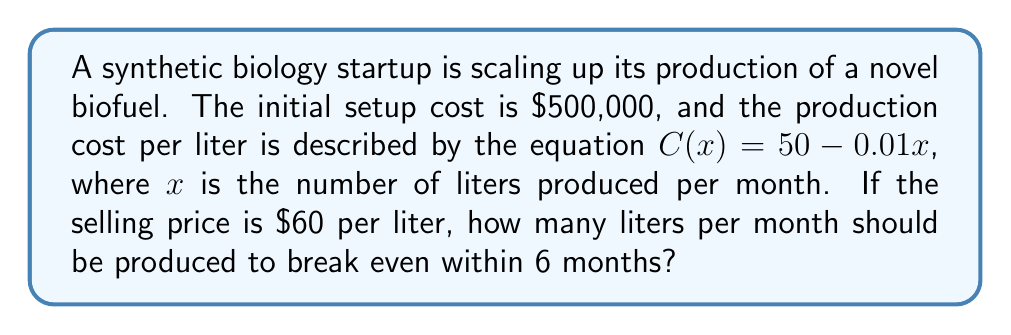Teach me how to tackle this problem. Let's approach this step-by-step:

1) First, let's define our variables:
   $x$ = number of liters produced per month
   $C(x)$ = production cost per liter
   $P$ = selling price per liter = $60

2) The total monthly revenue is given by:
   $R(x) = Px = 60x$

3) The total monthly cost is:
   $TC(x) = xC(x) = x(50 - 0.01x) = 50x - 0.01x^2$

4) The monthly profit is:
   $\pi(x) = R(x) - TC(x) = 60x - (50x - 0.01x^2) = 10x + 0.01x^2$

5) To break even within 6 months, the total profit should equal the initial setup cost:
   $6(10x + 0.01x^2) = 500,000$

6) Simplifying:
   $60x + 0.06x^2 = 500,000$
   $0.06x^2 + 60x - 500,000 = 0$

7) This is a quadratic equation. Let's solve it using the quadratic formula:
   $x = \frac{-b \pm \sqrt{b^2 - 4ac}}{2a}$

   Where $a = 0.06$, $b = 60$, and $c = -500,000$

8) Plugging in these values:
   $x = \frac{-60 \pm \sqrt{60^2 - 4(0.06)(-500,000)}}{2(0.06)}$

9) Simplifying:
   $x = \frac{-60 \pm \sqrt{3600 + 120,000}}{0.12} = \frac{-60 \pm \sqrt{123,600}}{0.12}$

10) Calculating:
    $x \approx 5,527.86$ or $x \approx -15,027.86$

11) Since we can't produce a negative number of liters, we take the positive solution.
Answer: 5,528 liters per month 